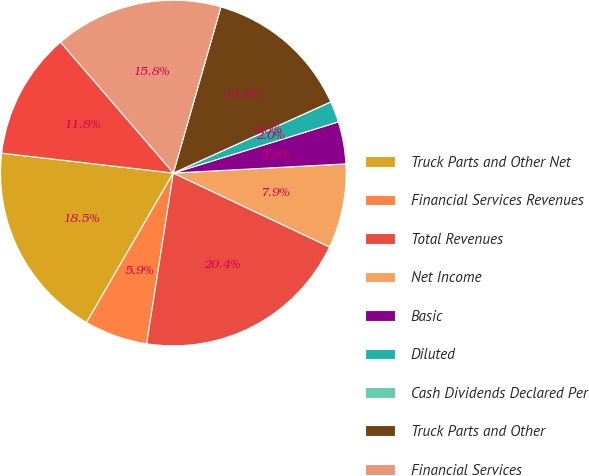Convert chart to OTSL. <chart><loc_0><loc_0><loc_500><loc_500><pie_chart><fcel>Truck Parts and Other Net<fcel>Financial Services Revenues<fcel>Total Revenues<fcel>Net Income<fcel>Basic<fcel>Diluted<fcel>Cash Dividends Declared Per<fcel>Truck Parts and Other<fcel>Financial Services<fcel>Financial Services Debt<nl><fcel>18.46%<fcel>5.91%<fcel>20.43%<fcel>7.88%<fcel>3.94%<fcel>1.97%<fcel>0.0%<fcel>13.8%<fcel>15.77%<fcel>11.83%<nl></chart> 